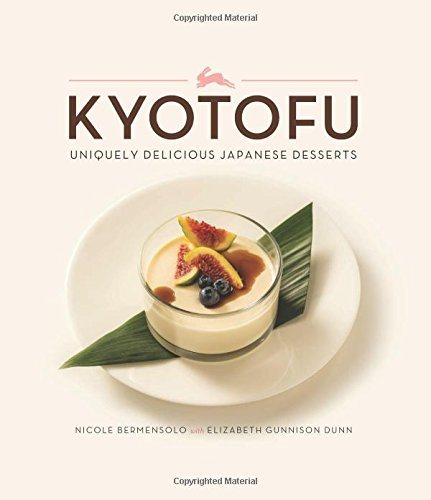Who is the author of this book? The book 'Kyotofu: Uniquely Delicious Japanese Desserts' is authored by Nicole Bermensolo, known for her expertise in blending traditional Japanese confectionery with modern dessert techniques. 